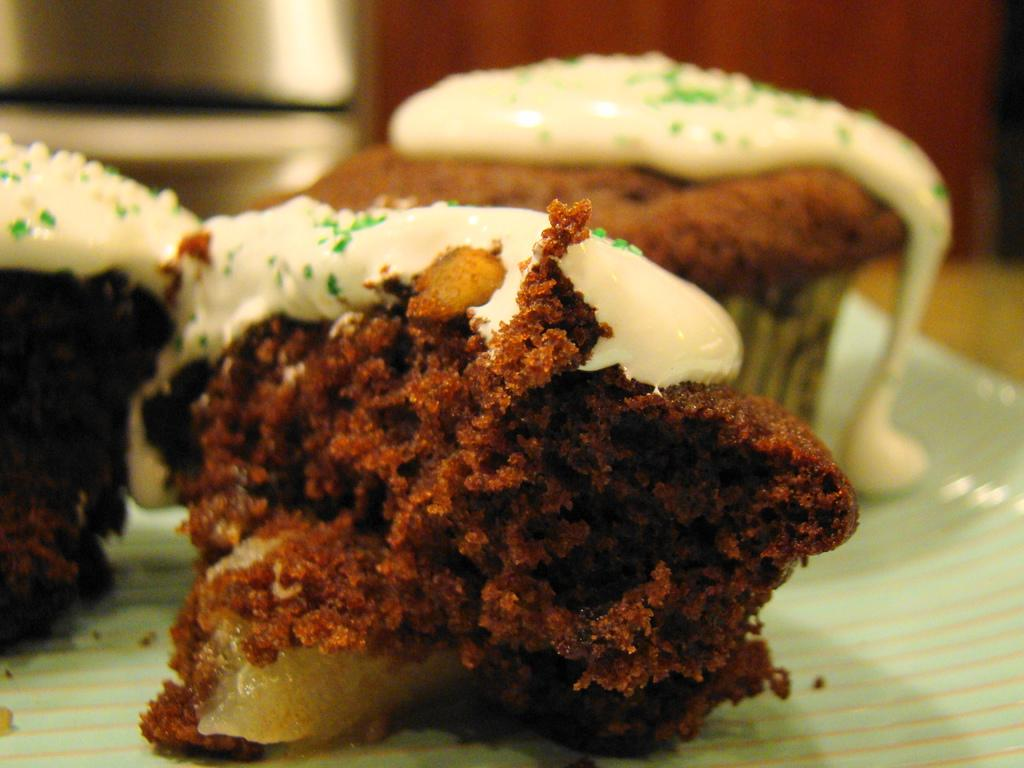How many cupcakes are visible in the image? There are three cupcakes in the image. What is the appearance of the cupcakes' toppings? The cupcakes have white-colored cream on them. Can you describe the overall quality of the image? The image is slightly blurry in the background. What type of scale is used to weigh the cub in the image? There is no scale or cub present in the image; it features three cupcakes with white-colored cream on them. 